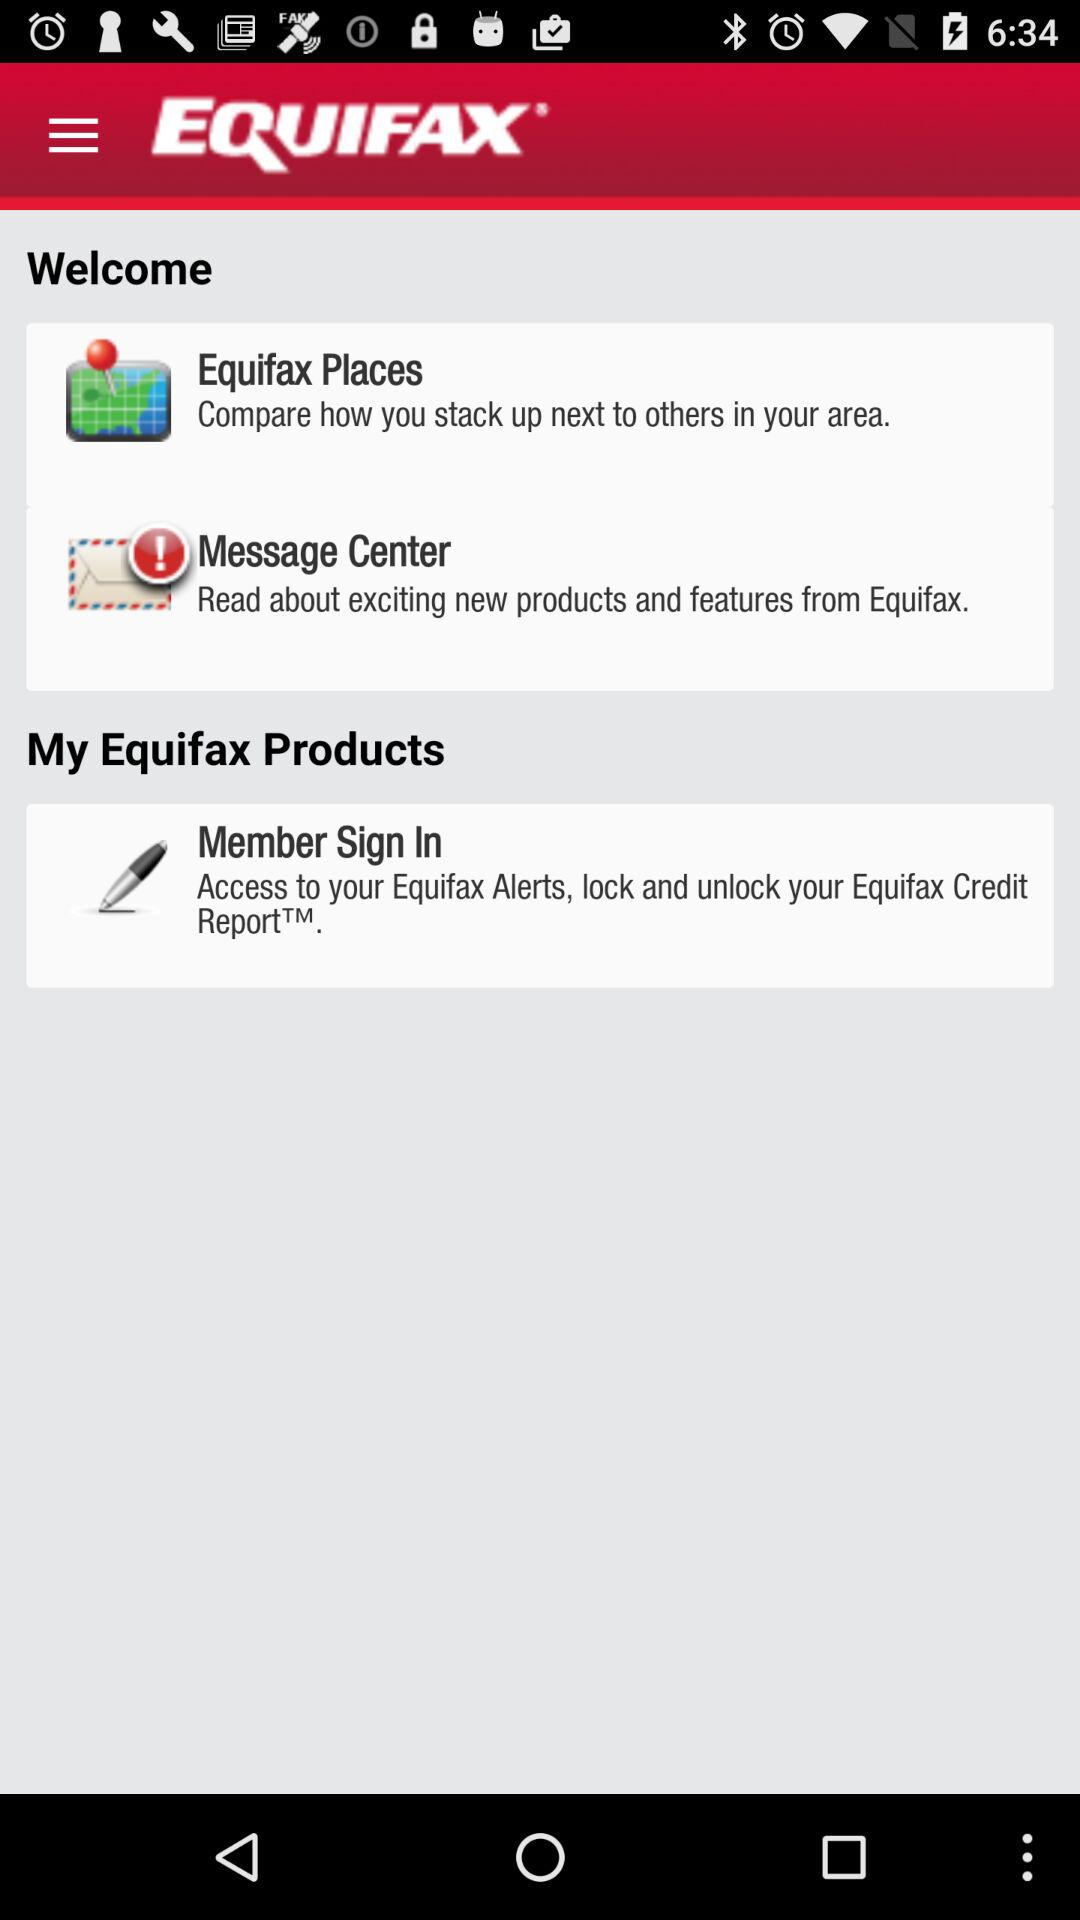What is the name of the application? The name of the application is "EQUIFAX". 